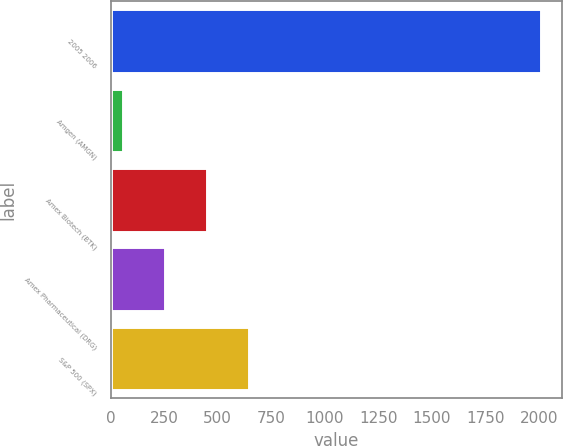Convert chart. <chart><loc_0><loc_0><loc_500><loc_500><bar_chart><fcel>2005 2006<fcel>Amgen (AMGN)<fcel>Amex Biotech (BTK)<fcel>Amex Pharmaceutical (DRG)<fcel>S&P 500 (SPX)<nl><fcel>2008<fcel>58.89<fcel>448.71<fcel>253.8<fcel>643.62<nl></chart> 